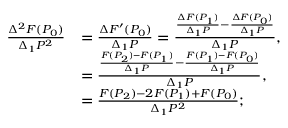<formula> <loc_0><loc_0><loc_500><loc_500>{ \begin{array} { r l } { { \frac { \Delta ^ { 2 } F ( P _ { 0 } ) } { \Delta _ { 1 } P ^ { 2 } } } } & { = { \frac { \Delta F ^ { \prime } ( P _ { 0 } ) } { \Delta _ { 1 } P } } = { \frac { { \frac { \Delta F ( P _ { 1 } ) } { \Delta _ { 1 } P } } - { \frac { \Delta F ( P _ { 0 } ) } { \Delta _ { 1 } P } } } { \Delta _ { 1 } P } } , } \\ & { = { \frac { { \frac { F ( P _ { 2 } ) - F ( P _ { 1 } ) } { \Delta _ { 1 } P } } - { \frac { F ( P _ { 1 } ) - F ( P _ { 0 } ) } { \Delta _ { 1 } P } } } { \Delta _ { 1 } P } } , } \\ & { = { \frac { F ( P _ { 2 } ) - 2 F ( P _ { 1 } ) + F ( P _ { 0 } ) } { \Delta _ { 1 } P ^ { 2 } } } ; } \end{array} }</formula> 